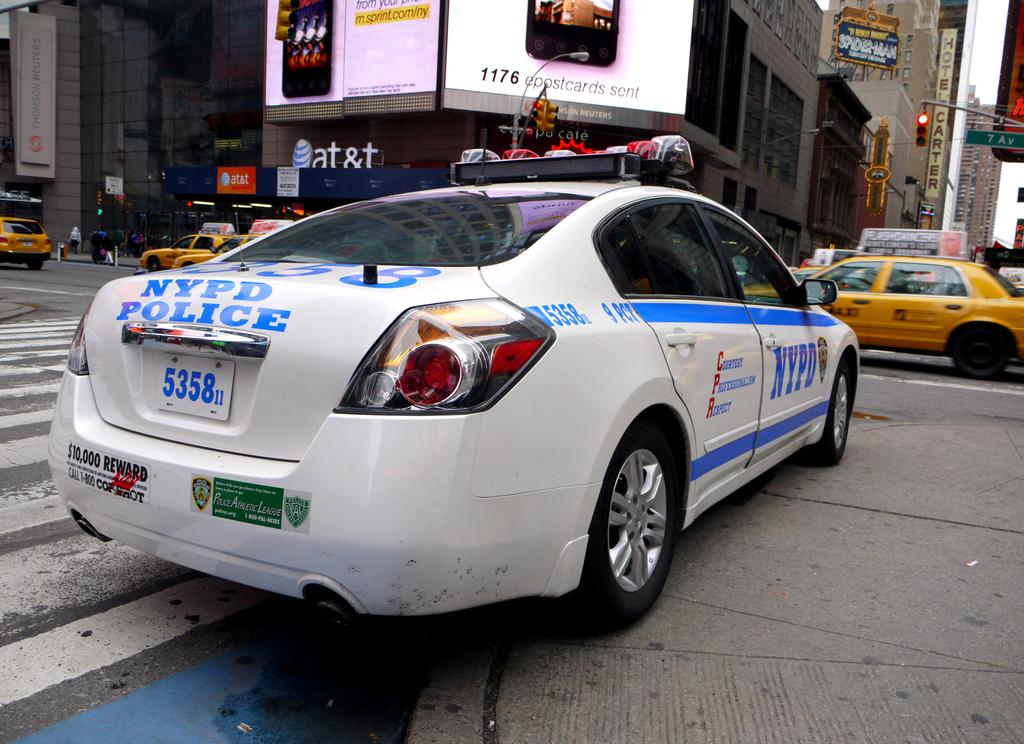<image>
Offer a succinct explanation of the picture presented. A white and blue NYPD Police car in a busy intersection. 